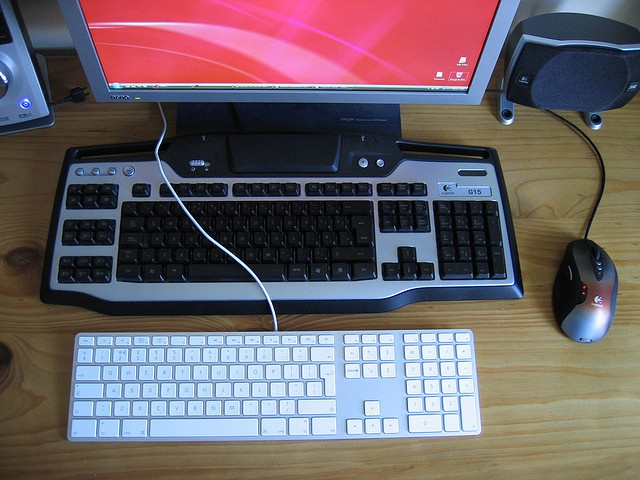Describe the objects in this image and their specific colors. I can see keyboard in navy, black, and gray tones, keyboard in navy, lightblue, and darkgray tones, tv in navy, salmon, violet, and gray tones, and mouse in navy, black, gray, and blue tones in this image. 